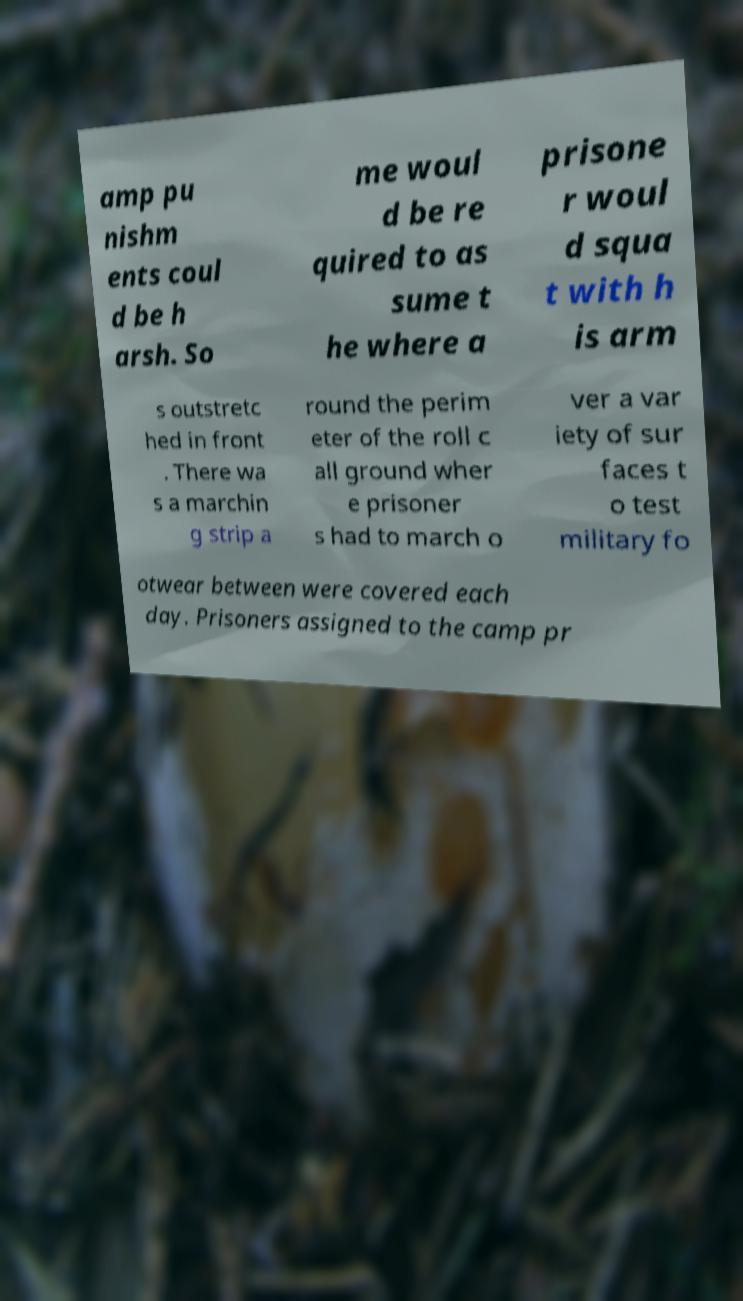Could you extract and type out the text from this image? amp pu nishm ents coul d be h arsh. So me woul d be re quired to as sume t he where a prisone r woul d squa t with h is arm s outstretc hed in front . There wa s a marchin g strip a round the perim eter of the roll c all ground wher e prisoner s had to march o ver a var iety of sur faces t o test military fo otwear between were covered each day. Prisoners assigned to the camp pr 